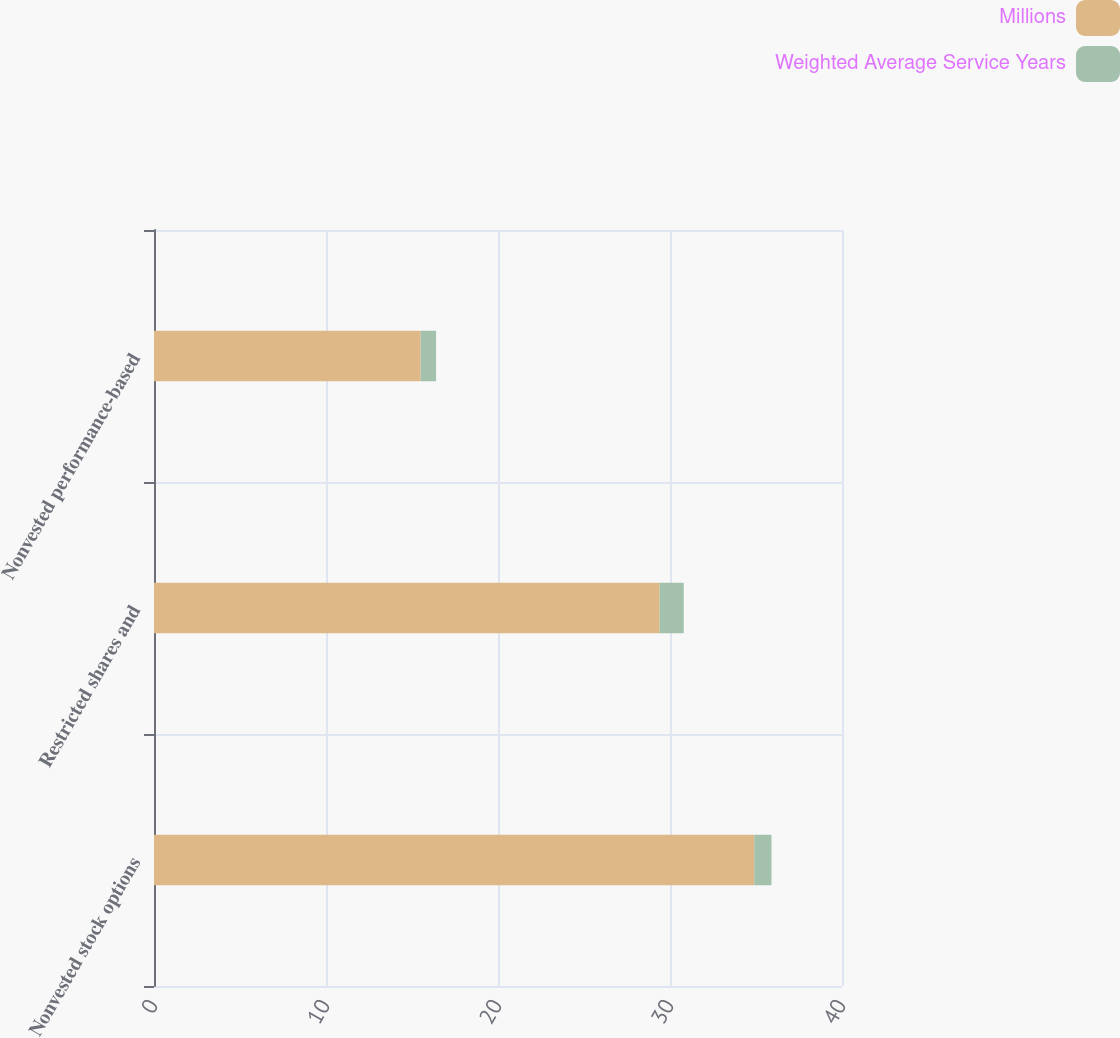Convert chart to OTSL. <chart><loc_0><loc_0><loc_500><loc_500><stacked_bar_chart><ecel><fcel>Nonvested stock options<fcel>Restricted shares and<fcel>Nonvested performance-based<nl><fcel>Millions<fcel>34.9<fcel>29.4<fcel>15.5<nl><fcel>Weighted Average Service Years<fcel>1<fcel>1.4<fcel>0.9<nl></chart> 